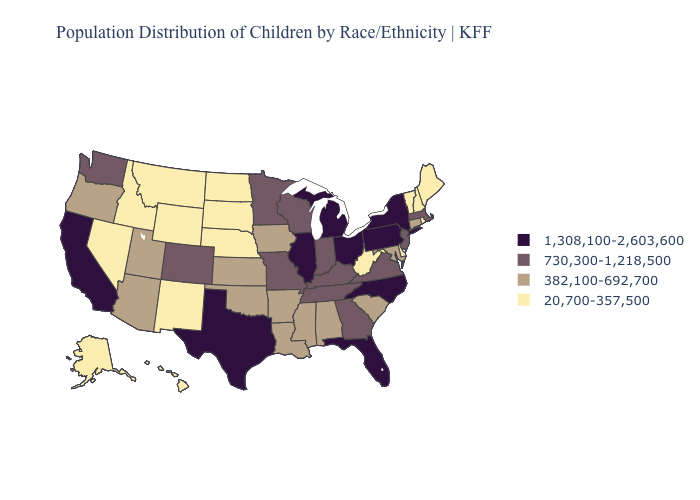What is the lowest value in the Northeast?
Give a very brief answer. 20,700-357,500. Does the map have missing data?
Answer briefly. No. Name the states that have a value in the range 730,300-1,218,500?
Be succinct. Colorado, Georgia, Indiana, Kentucky, Massachusetts, Minnesota, Missouri, New Jersey, Tennessee, Virginia, Washington, Wisconsin. Does Florida have the highest value in the USA?
Give a very brief answer. Yes. Is the legend a continuous bar?
Give a very brief answer. No. Name the states that have a value in the range 20,700-357,500?
Quick response, please. Alaska, Delaware, Hawaii, Idaho, Maine, Montana, Nebraska, Nevada, New Hampshire, New Mexico, North Dakota, Rhode Island, South Dakota, Vermont, West Virginia, Wyoming. Does the first symbol in the legend represent the smallest category?
Short answer required. No. Name the states that have a value in the range 730,300-1,218,500?
Short answer required. Colorado, Georgia, Indiana, Kentucky, Massachusetts, Minnesota, Missouri, New Jersey, Tennessee, Virginia, Washington, Wisconsin. What is the lowest value in the MidWest?
Write a very short answer. 20,700-357,500. Does the map have missing data?
Be succinct. No. Does Pennsylvania have the lowest value in the Northeast?
Be succinct. No. What is the value of Utah?
Keep it brief. 382,100-692,700. What is the lowest value in states that border Colorado?
Keep it brief. 20,700-357,500. What is the value of Wyoming?
Concise answer only. 20,700-357,500. 